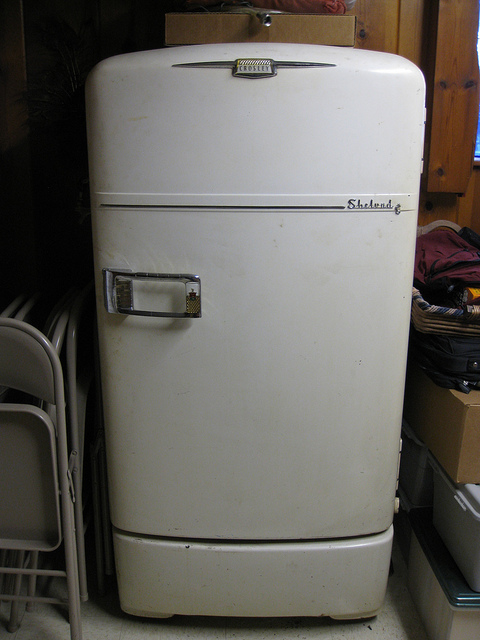Read and extract the text from this image. Sheland 